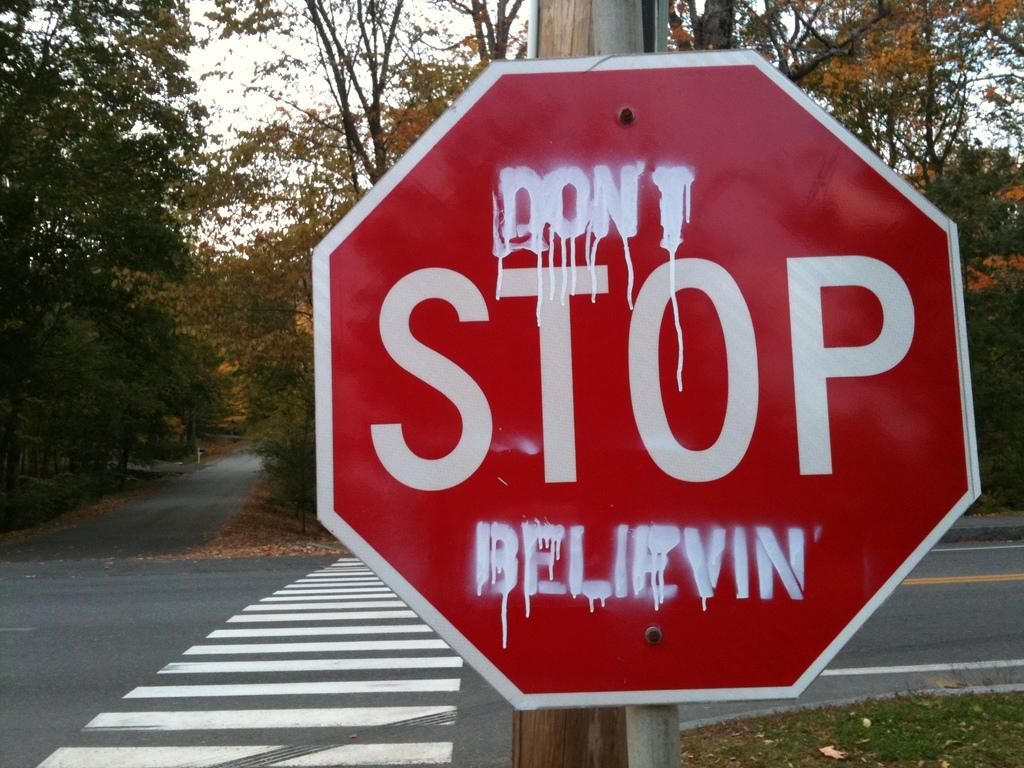<image>
Provide a brief description of the given image. A red stop sign says "DONT STOP BELEVIN." 